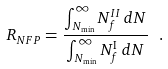<formula> <loc_0><loc_0><loc_500><loc_500>R _ { N F P } = \frac { \int _ { N _ { \min } } ^ { \infty } N _ { f } ^ { I I } \, d N } { \int _ { N _ { \min } } ^ { \infty } N _ { f } ^ { \mathrm I } \, d N } \ .</formula> 